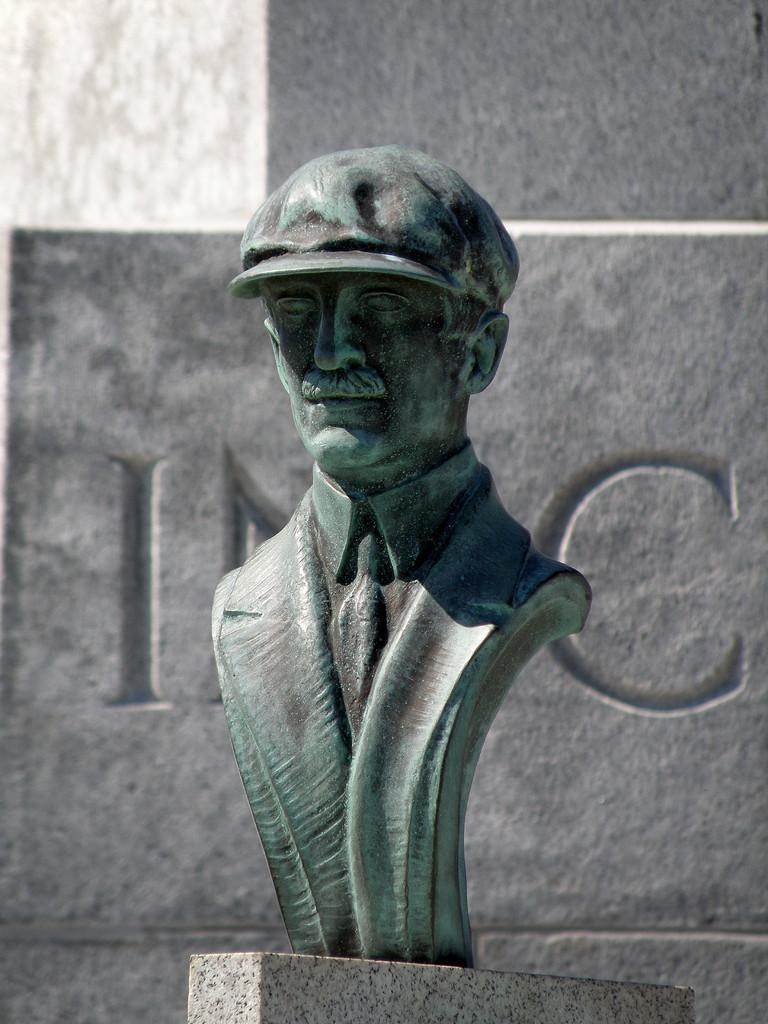What is the main subject of subject of the image? There is a sculpture of a man in the image. What is located behind the sculpture? There is a wall behind the sculpture. What can be seen on the wall? There is text on the wall. What flavor of ice cream is being served at the beach in the image? There is no ice cream or beach present in the image; it features a sculpture of a man and a wall with text. How does the sculpture end in the image? The sculpture does not end in the image; it is a complete representation of a man. 